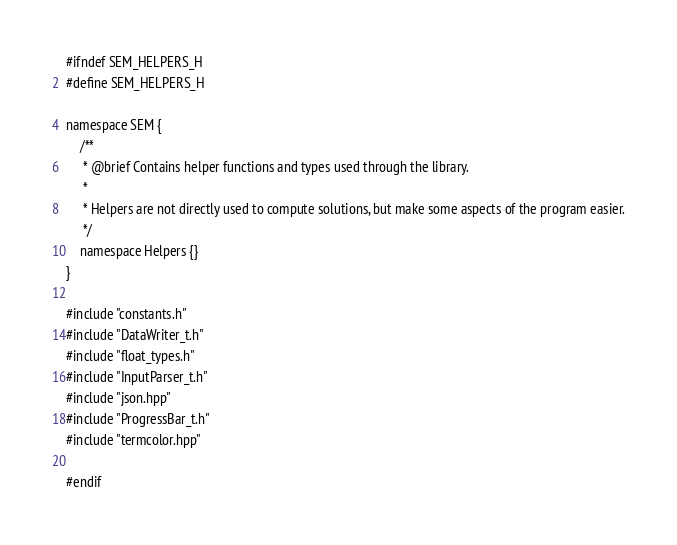<code> <loc_0><loc_0><loc_500><loc_500><_C_>#ifndef SEM_HELPERS_H
#define SEM_HELPERS_H

namespace SEM { 
    /**
     * @brief Contains helper functions and types used through the library.
     * 
     * Helpers are not directly used to compute solutions, but make some aspects of the program easier.
     */
    namespace Helpers {}
}

#include "constants.h"
#include "DataWriter_t.h"
#include "float_types.h"
#include "InputParser_t.h"
#include "json.hpp"
#include "ProgressBar_t.h"
#include "termcolor.hpp"

#endif</code> 